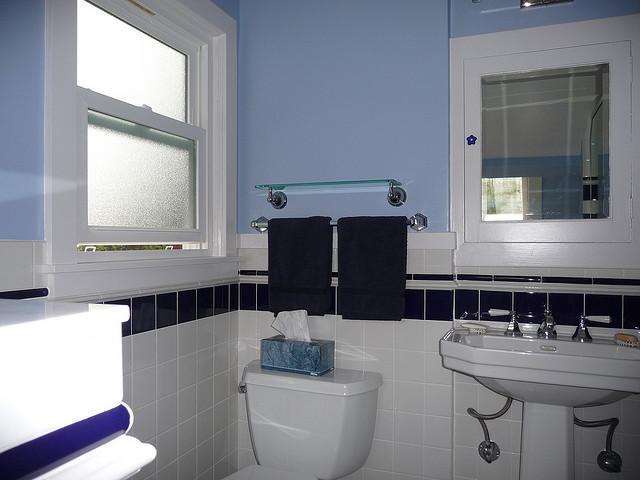How many towels are hanging on the rack?
Give a very brief answer. 2. How many toilets are in the photo?
Give a very brief answer. 1. 